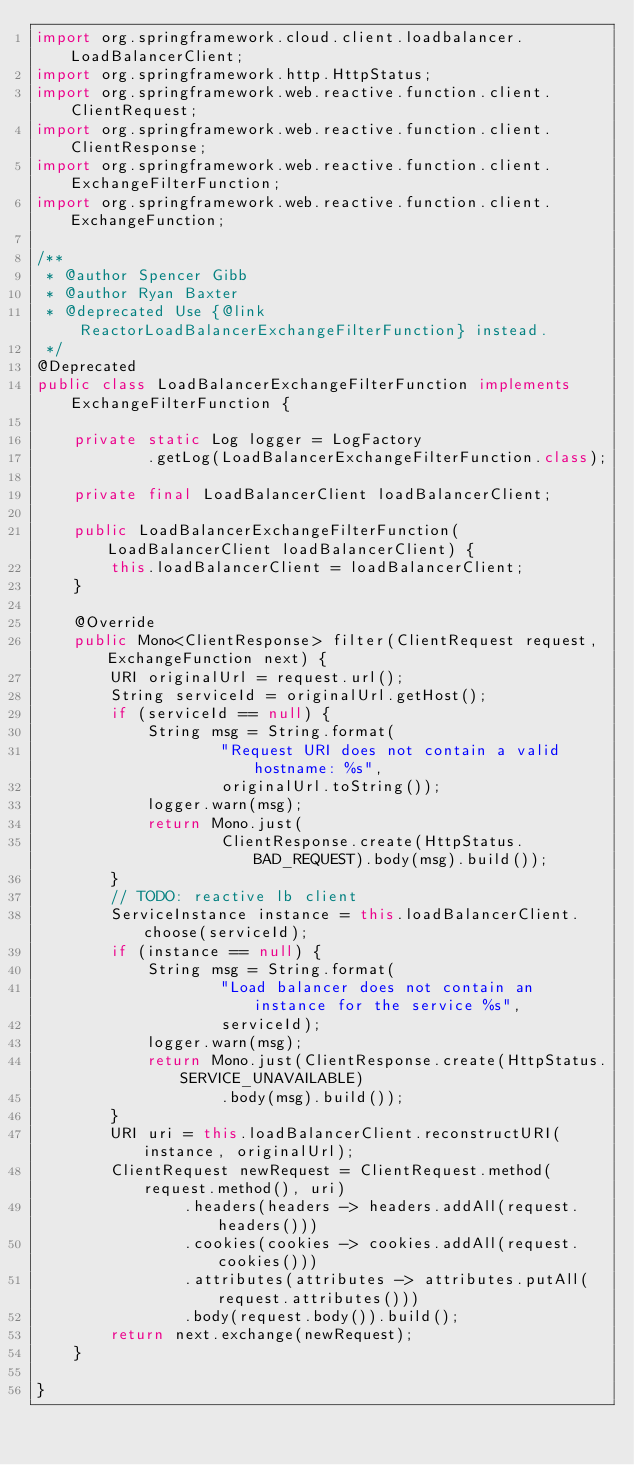Convert code to text. <code><loc_0><loc_0><loc_500><loc_500><_Java_>import org.springframework.cloud.client.loadbalancer.LoadBalancerClient;
import org.springframework.http.HttpStatus;
import org.springframework.web.reactive.function.client.ClientRequest;
import org.springframework.web.reactive.function.client.ClientResponse;
import org.springframework.web.reactive.function.client.ExchangeFilterFunction;
import org.springframework.web.reactive.function.client.ExchangeFunction;

/**
 * @author Spencer Gibb
 * @author Ryan Baxter
 * @deprecated Use {@link ReactorLoadBalancerExchangeFilterFunction} instead.
 */
@Deprecated
public class LoadBalancerExchangeFilterFunction implements ExchangeFilterFunction {

	private static Log logger = LogFactory
			.getLog(LoadBalancerExchangeFilterFunction.class);

	private final LoadBalancerClient loadBalancerClient;

	public LoadBalancerExchangeFilterFunction(LoadBalancerClient loadBalancerClient) {
		this.loadBalancerClient = loadBalancerClient;
	}

	@Override
	public Mono<ClientResponse> filter(ClientRequest request, ExchangeFunction next) {
		URI originalUrl = request.url();
		String serviceId = originalUrl.getHost();
		if (serviceId == null) {
			String msg = String.format(
					"Request URI does not contain a valid hostname: %s",
					originalUrl.toString());
			logger.warn(msg);
			return Mono.just(
					ClientResponse.create(HttpStatus.BAD_REQUEST).body(msg).build());
		}
		// TODO: reactive lb client
		ServiceInstance instance = this.loadBalancerClient.choose(serviceId);
		if (instance == null) {
			String msg = String.format(
					"Load balancer does not contain an instance for the service %s",
					serviceId);
			logger.warn(msg);
			return Mono.just(ClientResponse.create(HttpStatus.SERVICE_UNAVAILABLE)
					.body(msg).build());
		}
		URI uri = this.loadBalancerClient.reconstructURI(instance, originalUrl);
		ClientRequest newRequest = ClientRequest.method(request.method(), uri)
				.headers(headers -> headers.addAll(request.headers()))
				.cookies(cookies -> cookies.addAll(request.cookies()))
				.attributes(attributes -> attributes.putAll(request.attributes()))
				.body(request.body()).build();
		return next.exchange(newRequest);
	}

}
</code> 